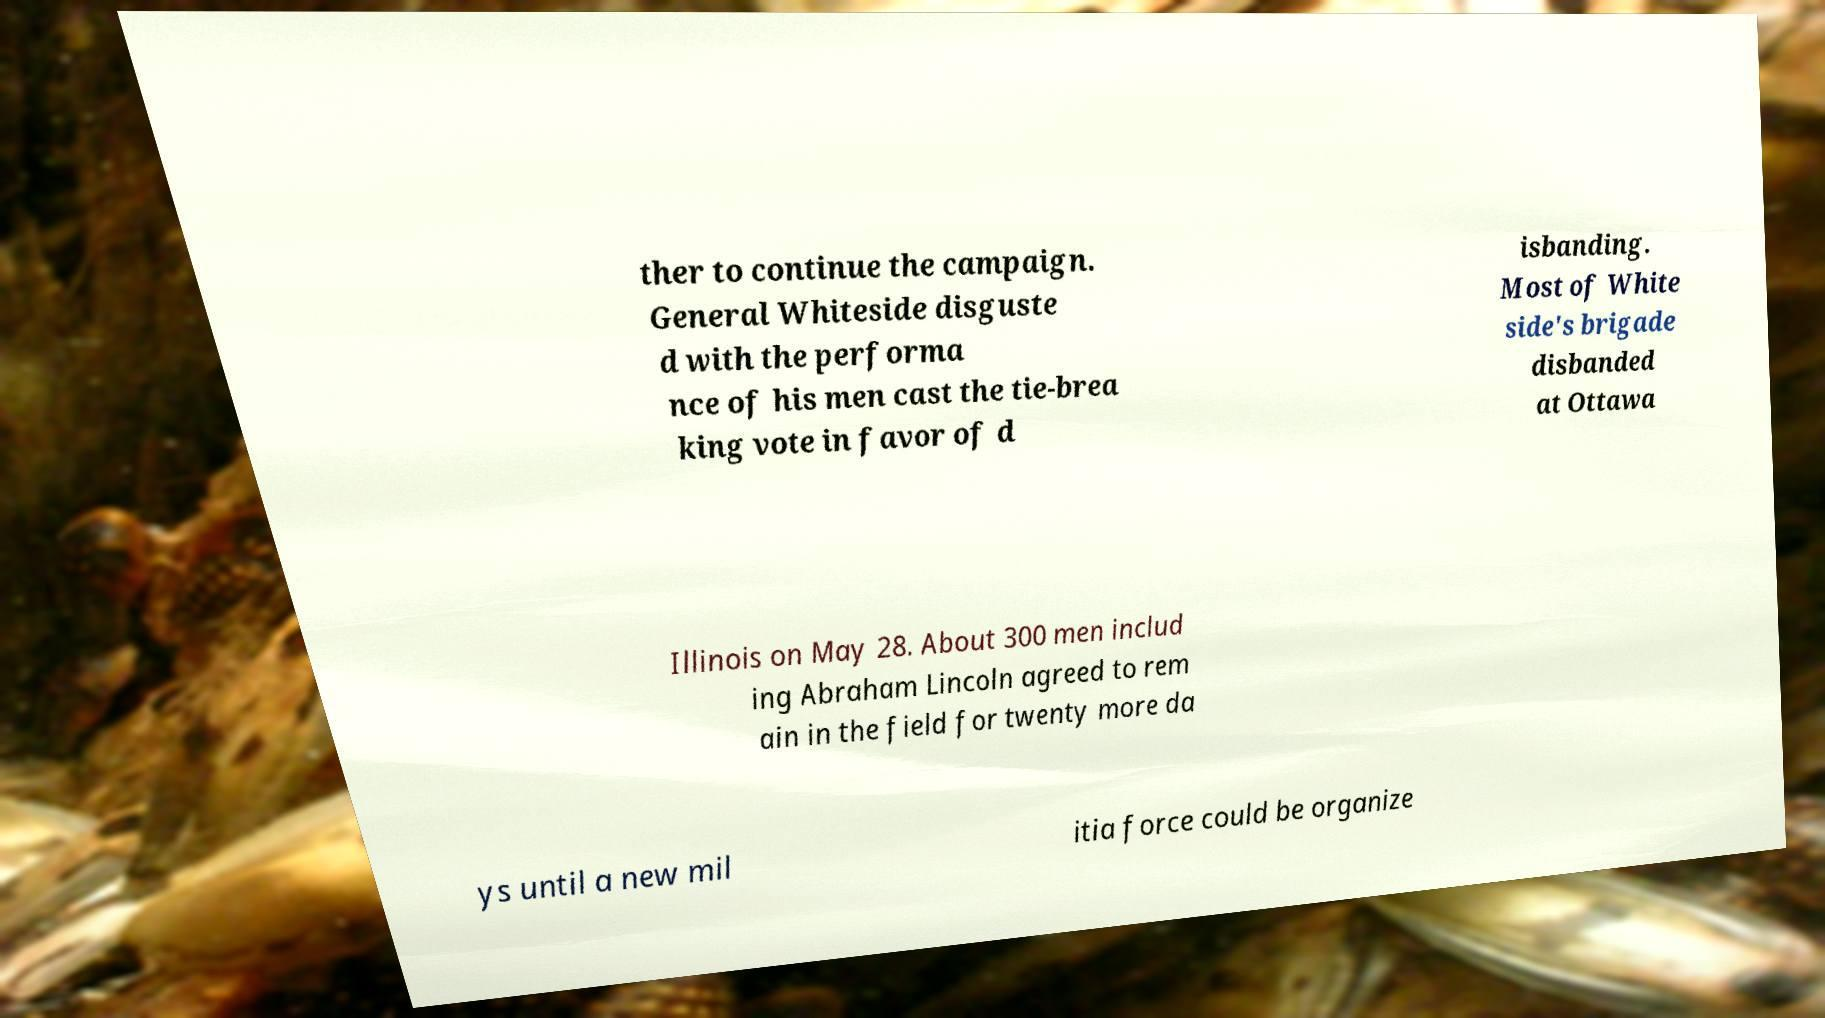Can you read and provide the text displayed in the image?This photo seems to have some interesting text. Can you extract and type it out for me? ther to continue the campaign. General Whiteside disguste d with the performa nce of his men cast the tie-brea king vote in favor of d isbanding. Most of White side's brigade disbanded at Ottawa Illinois on May 28. About 300 men includ ing Abraham Lincoln agreed to rem ain in the field for twenty more da ys until a new mil itia force could be organize 